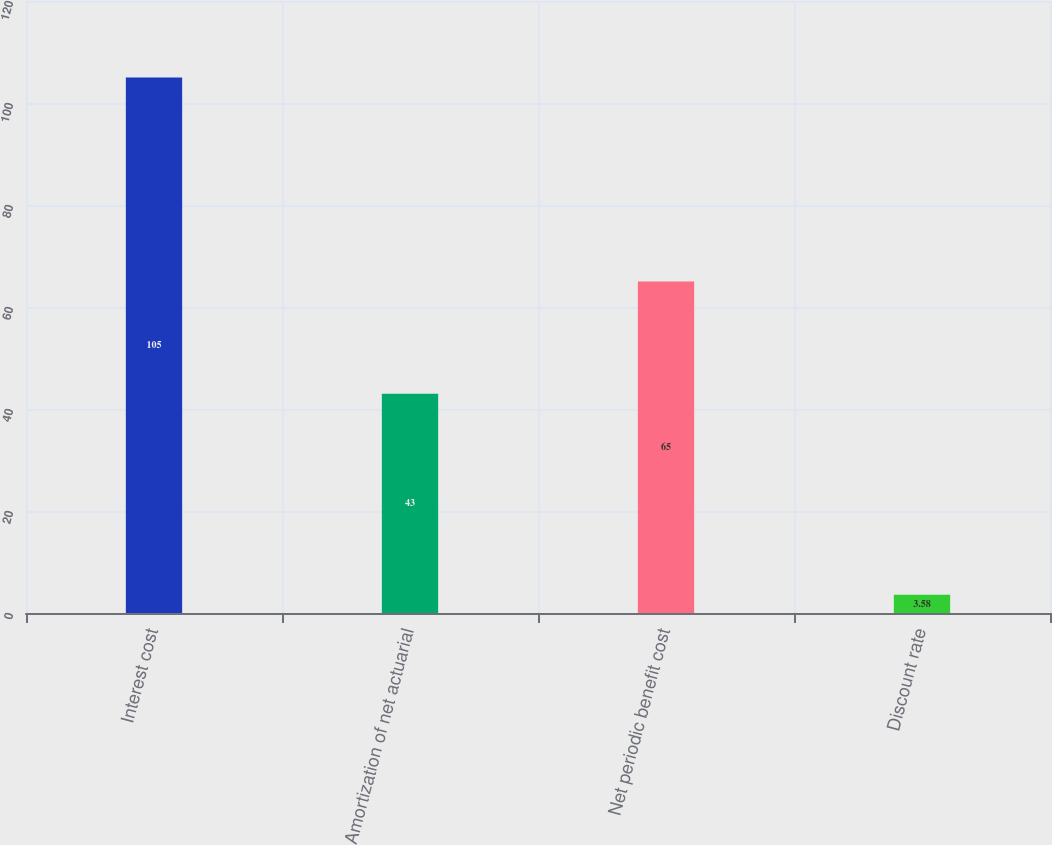Convert chart to OTSL. <chart><loc_0><loc_0><loc_500><loc_500><bar_chart><fcel>Interest cost<fcel>Amortization of net actuarial<fcel>Net periodic benefit cost<fcel>Discount rate<nl><fcel>105<fcel>43<fcel>65<fcel>3.58<nl></chart> 